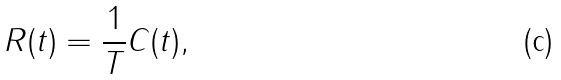Convert formula to latex. <formula><loc_0><loc_0><loc_500><loc_500>R ( t ) = \frac { 1 } { T } C ( t ) ,</formula> 